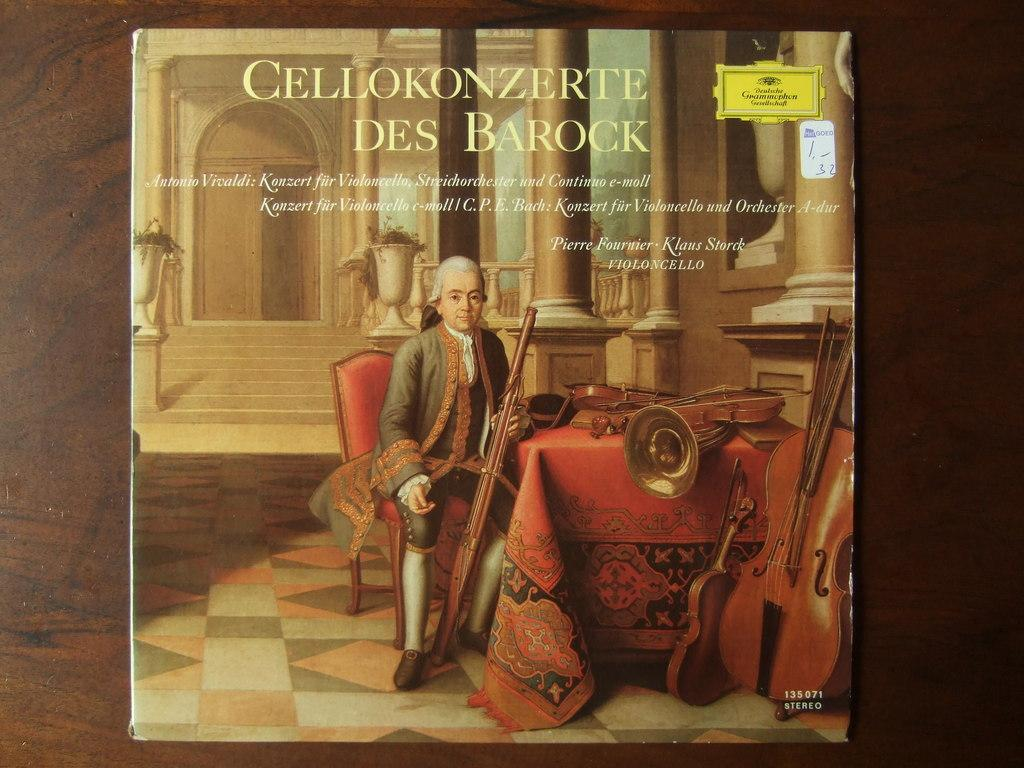<image>
Give a short and clear explanation of the subsequent image. A record with a man and musical instruments entitled Cellokonzerte Des Barock. 